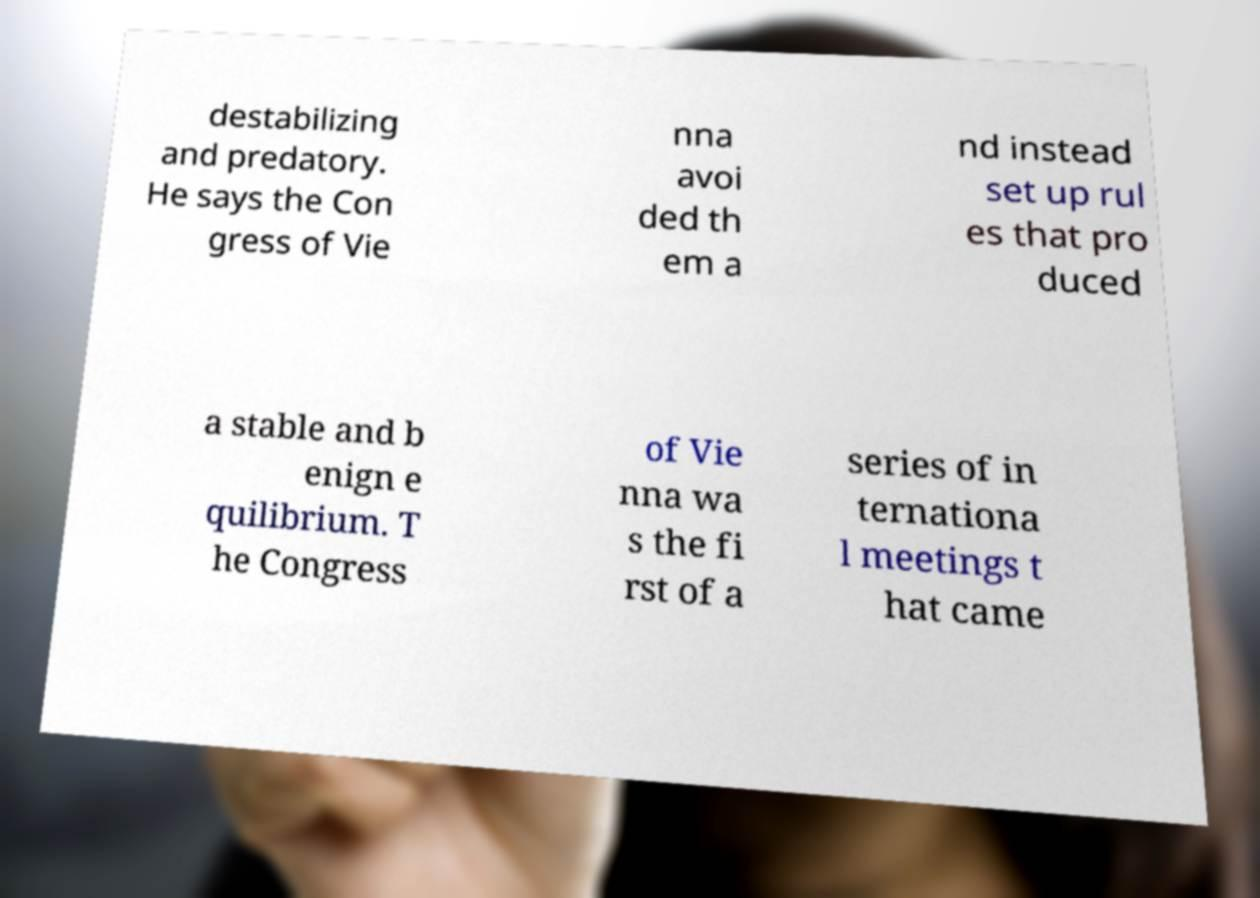What messages or text are displayed in this image? I need them in a readable, typed format. destabilizing and predatory. He says the Con gress of Vie nna avoi ded th em a nd instead set up rul es that pro duced a stable and b enign e quilibrium. T he Congress of Vie nna wa s the fi rst of a series of in ternationa l meetings t hat came 